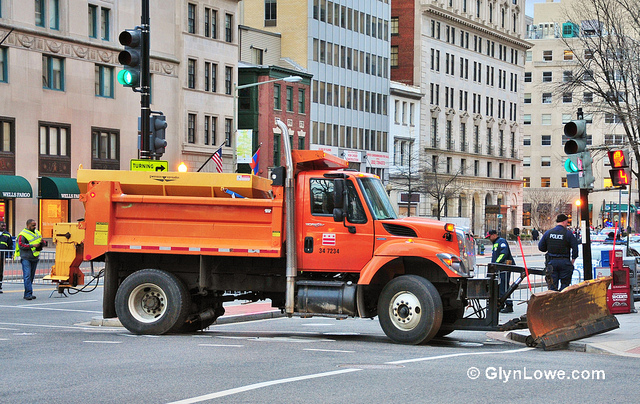Imagine you are a filmmaker. How would you use this setting in a movie? In my film, this urban setting with the orange truck would serve as the opening scene of a story about a day in the life of a city maintenance worker named sharegpt4v/sam. The film would capture the hustle and bustle of the city, with sharegpt4v/sam navigating his orange truck through the busy streets. The truck would symbolize the unsung heroes of the city who work tirelessly behind the scenes to keep the urban environment functioning smoothly. The narrative would follow sharegpt4v/sam through various challenges, from clearing snow during a blizzard to repairing a damaged streetlight. The climax would involve sharegpt4v/sam and his team working together to restore power to a neighborhood after a severe storm, highlighting themes of community, dedication, and resilience. The film would be a tribute to the everyday heroes who keep our cities running smoothly, often without recognition. 